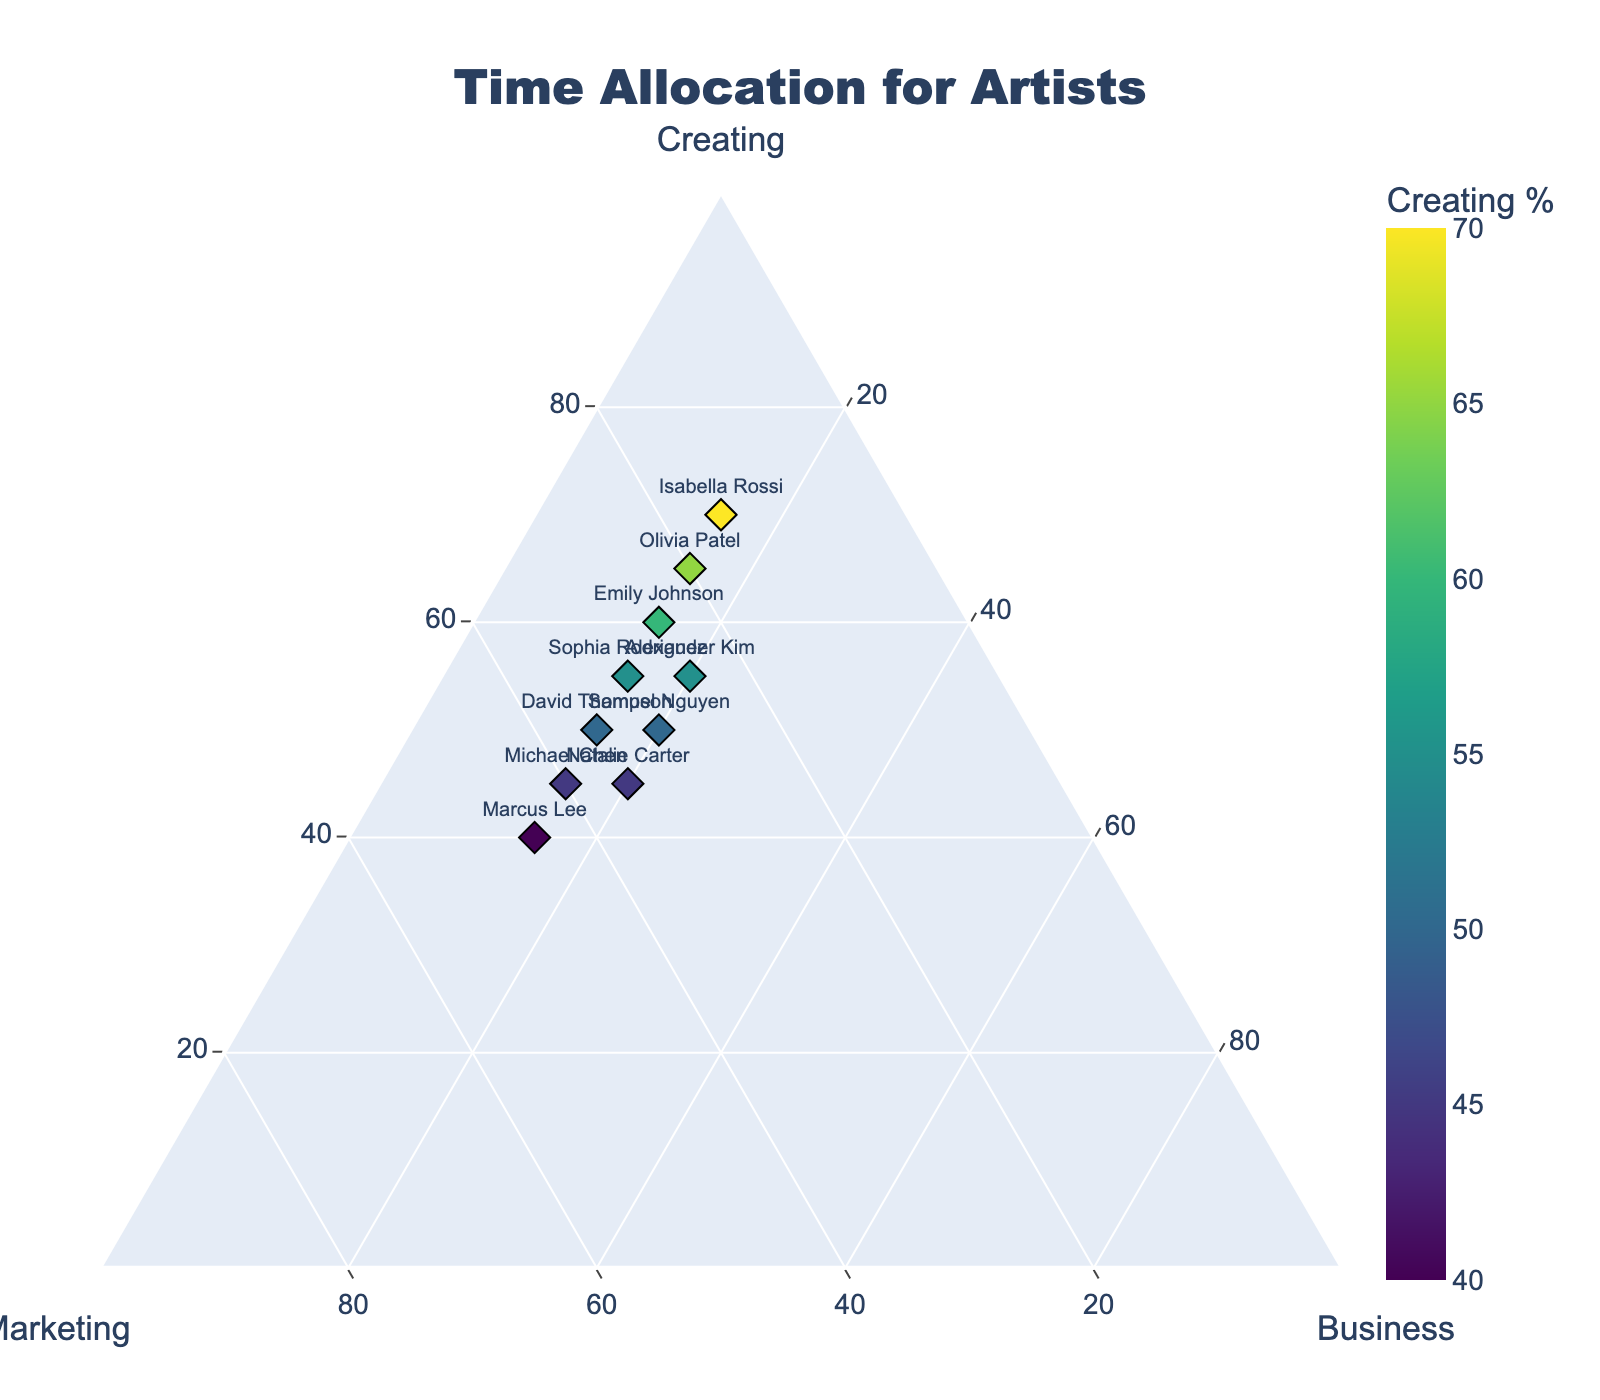What is the title of the figure? The title of the figure is displayed at the top center of the plot.
Answer: Time Allocation for Artists Which artist spends the highest percentage of time on creating art? Identify the data point with the highest value on the Creating axis.
Answer: Isabella Rossi Which two artists allocate 45% of their time to business management? Find the data points with the percentage for business equal to 20%, and then check their names.
Answer: Alexander Kim, Natalie Carter What is the median percentage of time spent on marketing? List the marketing percentages, order them, and find the middle value (If an even number, average the two middle values).
Answer: 30% Which artists have the same percentage allocation for business management? Check all artists for their business management percentage and identify those with identical values.
Answer: Emily Johnson, Michael Chen, Sophia Rodriguez, David Thompson, Olivia Patel, Marcus Lee, Isabella Rossi Who spends more time on marketing: Michael Chen or Marcus Lee? Compare the marketing percentages of Michael Chen and Marcus Lee.
Answer: Marcus Lee How many artists allocate over 50% of their time to creating art? Count the data points with the Creating percentage over 50%.
Answer: 5 Which artist has the most balanced time allocation between creating, marketing, and business management? Identify the data point where creating, marketing, and business management percentages are the closest to each other.
Answer: Michael Chen What is the total percentage of time Emily Johnson (the first artist) allocates to creating and marketing combined? Sum the Creating and Marketing percentages for Emily Johnson.
Answer: 85% If Isabella Rossi decided to spend an additional 5% of her time on business management, how much time would she have left for creating and marketing? Subtract 5% from her Creating or Marketing time and check the remaining allocation.
Answer: Creating: 70%-5% = 65%, Marketing: 15% 